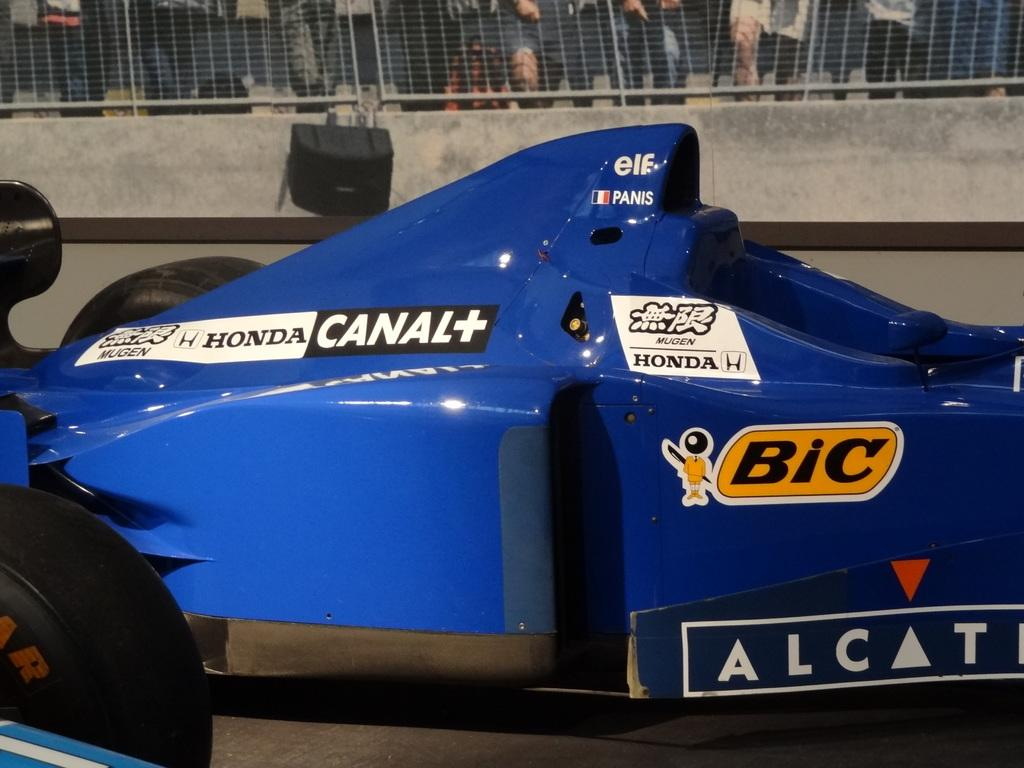What is the main subject of the image? The main subject of the image is a vehicle on a platform. Can you describe any other objects or features in the image? Yes, there is an object on a wall in the background and people standing at a fence in the background. What type of line can be seen on the face of the vehicle in the image? There is no line visible on the face of the vehicle in the image. Can you tell me how many scissors are being used by the people at the fence in the image? There are no scissors present in the image; the people at the fence are not using any tools. 